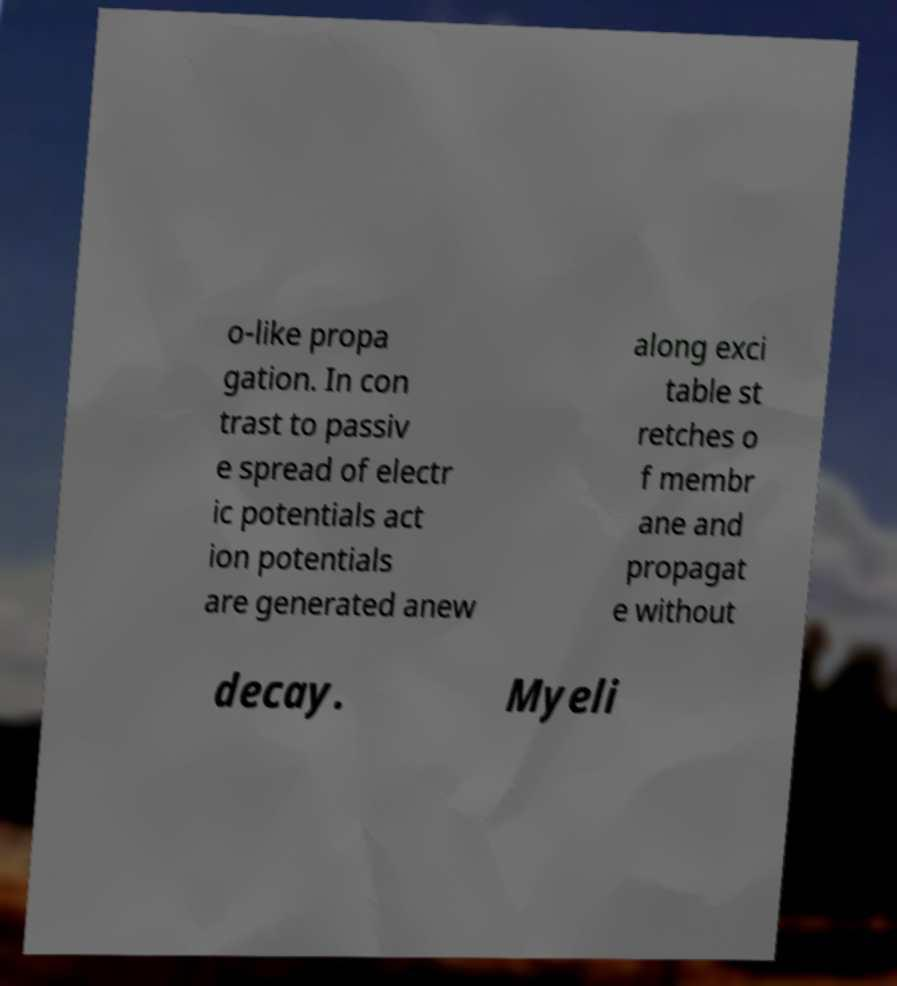Could you assist in decoding the text presented in this image and type it out clearly? o-like propa gation. In con trast to passiv e spread of electr ic potentials act ion potentials are generated anew along exci table st retches o f membr ane and propagat e without decay. Myeli 